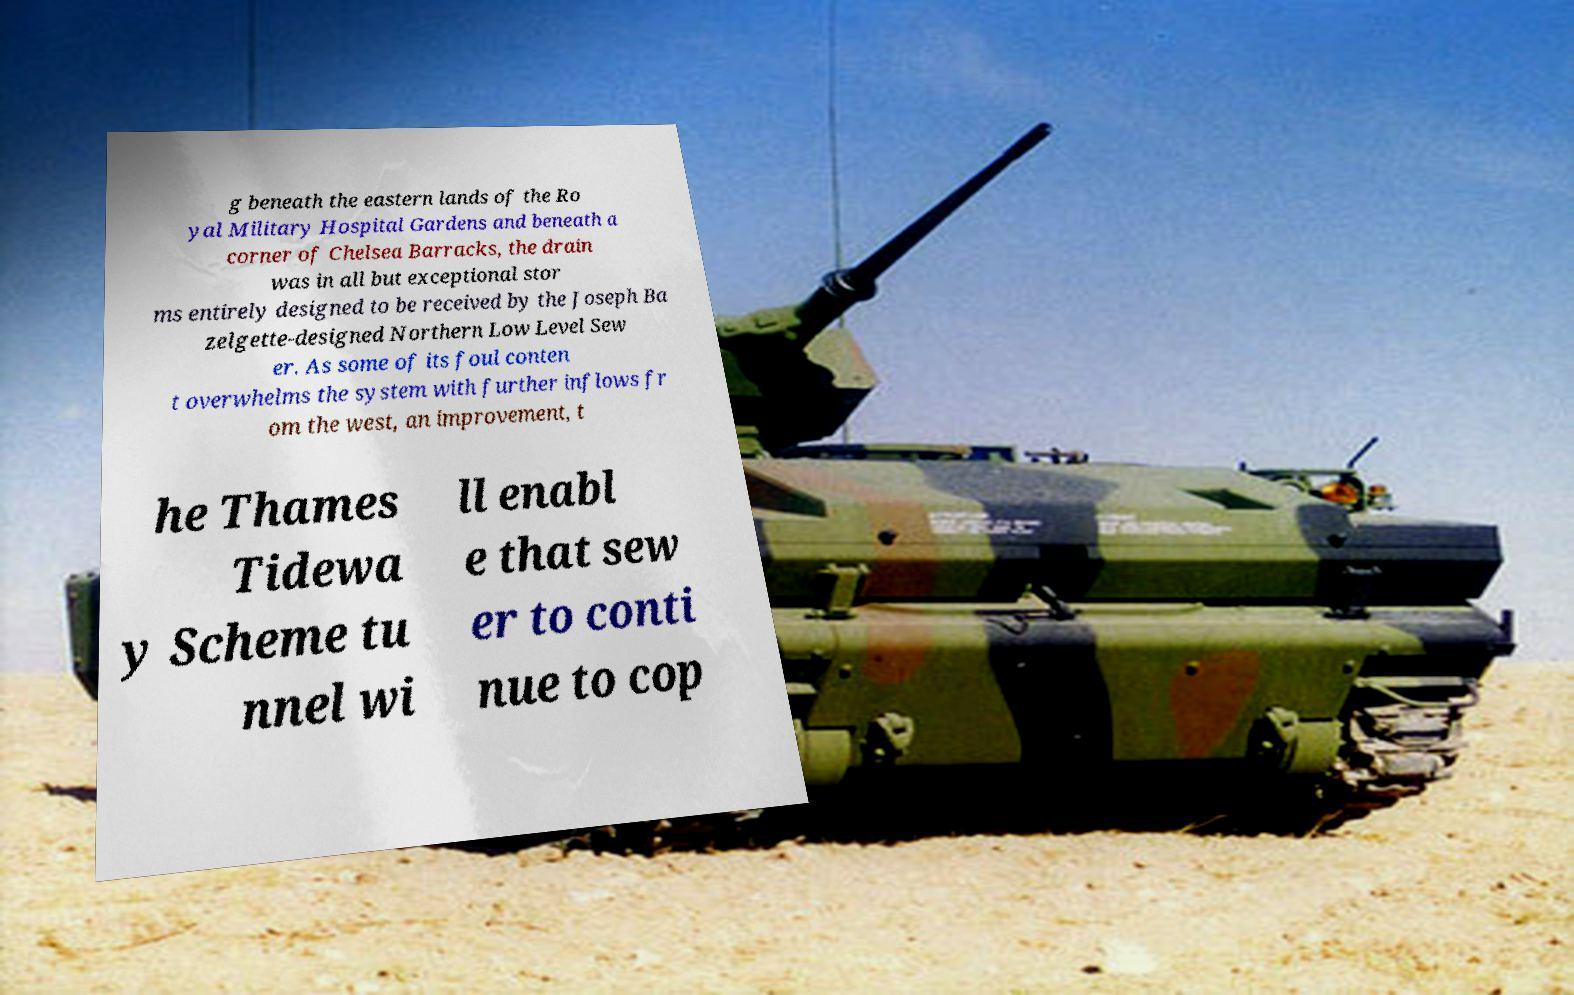Could you extract and type out the text from this image? g beneath the eastern lands of the Ro yal Military Hospital Gardens and beneath a corner of Chelsea Barracks, the drain was in all but exceptional stor ms entirely designed to be received by the Joseph Ba zelgette-designed Northern Low Level Sew er. As some of its foul conten t overwhelms the system with further inflows fr om the west, an improvement, t he Thames Tidewa y Scheme tu nnel wi ll enabl e that sew er to conti nue to cop 